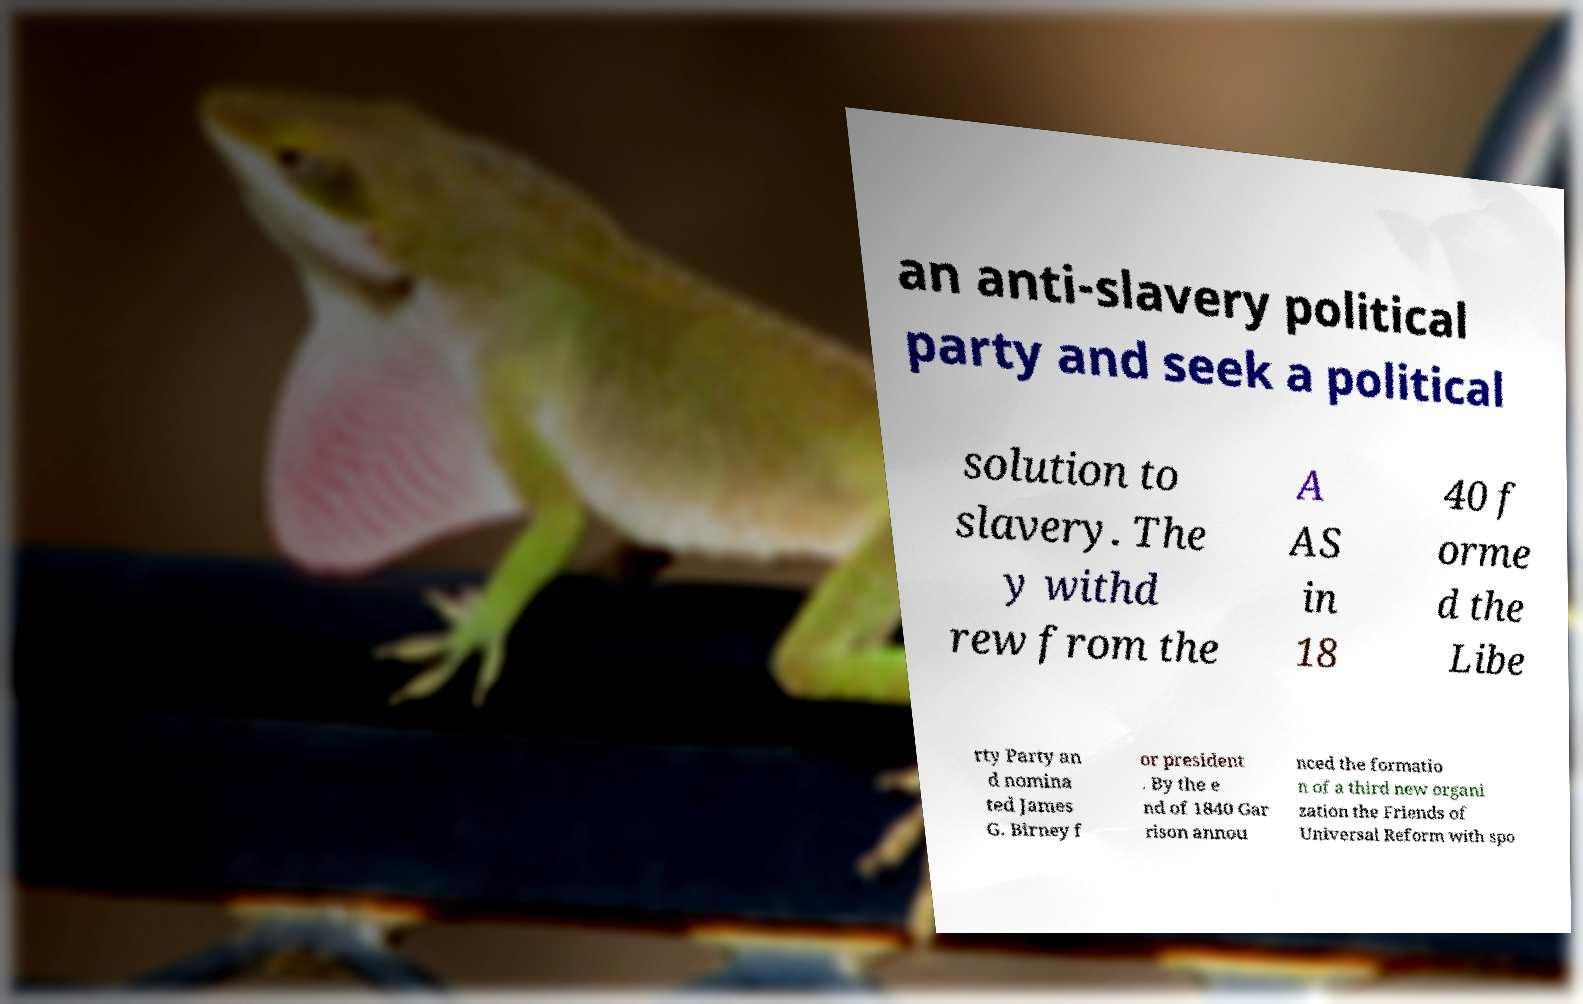Could you extract and type out the text from this image? an anti-slavery political party and seek a political solution to slavery. The y withd rew from the A AS in 18 40 f orme d the Libe rty Party an d nomina ted James G. Birney f or president . By the e nd of 1840 Gar rison annou nced the formatio n of a third new organi zation the Friends of Universal Reform with spo 